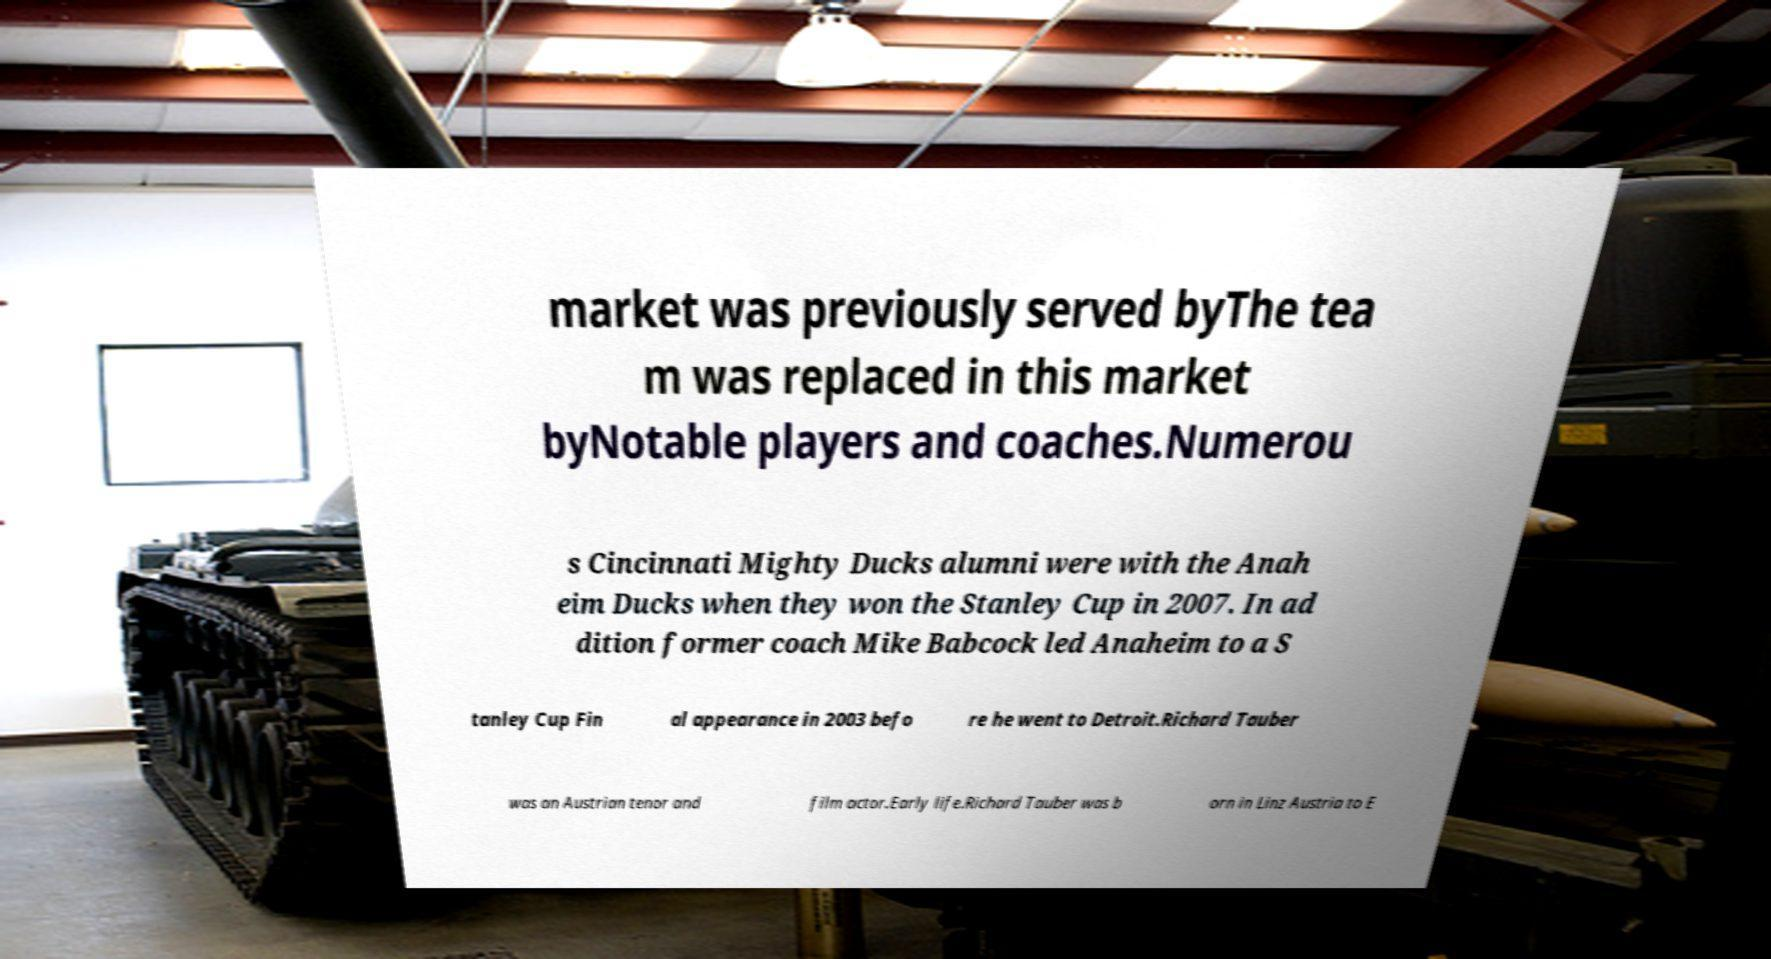Please read and relay the text visible in this image. What does it say? market was previously served byThe tea m was replaced in this market byNotable players and coaches.Numerou s Cincinnati Mighty Ducks alumni were with the Anah eim Ducks when they won the Stanley Cup in 2007. In ad dition former coach Mike Babcock led Anaheim to a S tanley Cup Fin al appearance in 2003 befo re he went to Detroit.Richard Tauber was an Austrian tenor and film actor.Early life.Richard Tauber was b orn in Linz Austria to E 